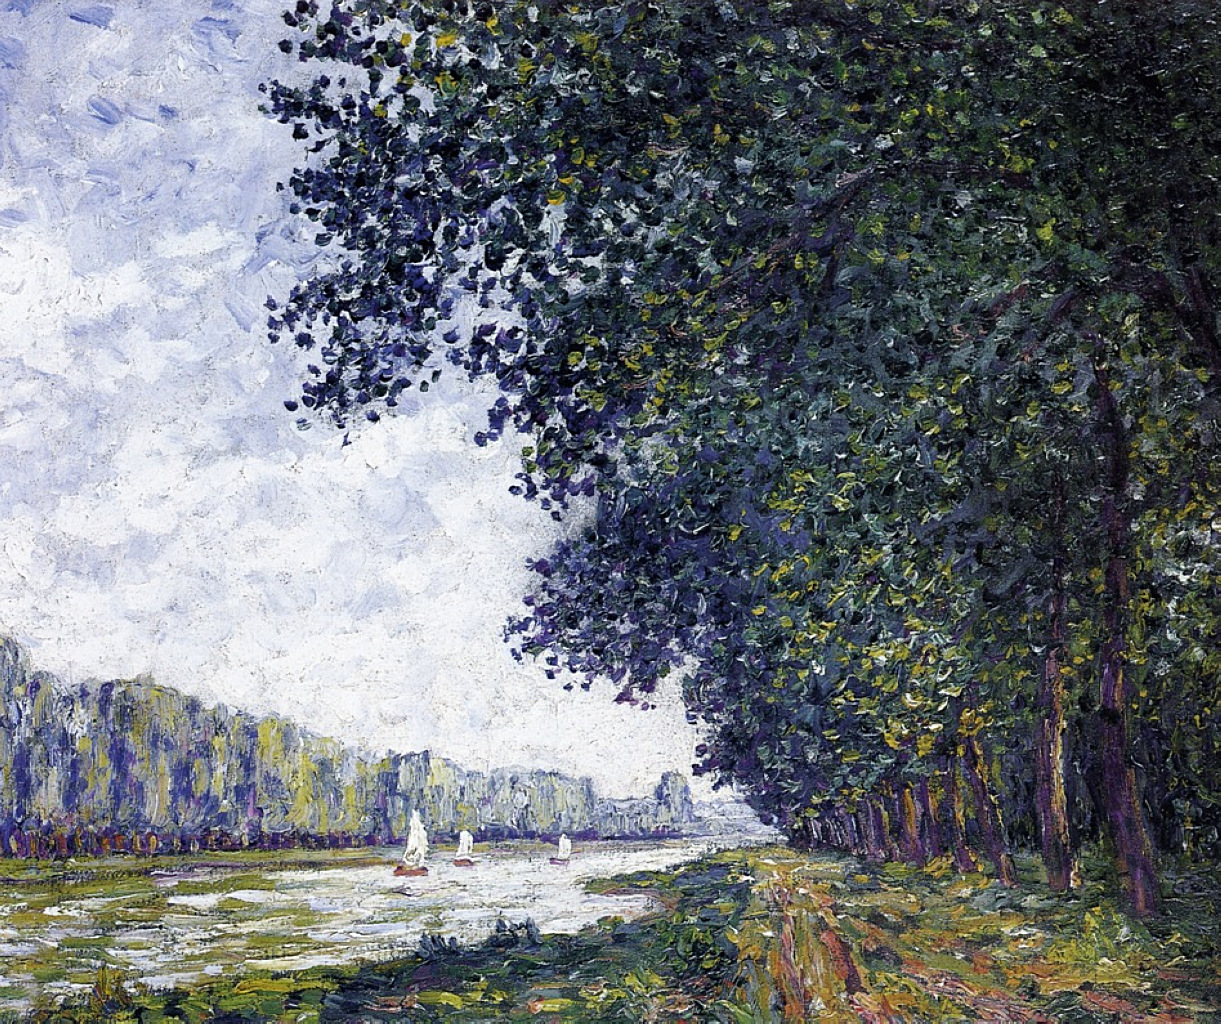Can you describe how the light is used throughout the painting? In the painting, light is masterfully used to evoke a sense of time and mood. The soft, diffused light suggests a calm, serene day with perhaps a few clouds filtering the sunlight. Light reflections on the water create a shimmering effect, enhancing the tranquility of the scene. The sunlight gently illuminates the leaves of the trees and casts subtle shadows, adding depth and dimension to the landscape. The use of light not only accentuates the natural beauty of the scene but also reinforces the peaceful ambiance that permeates the painting. What might the artist have felt or intended to convey with this painting? The artist likely intended to convey a sense of peace, serenity, and the ephemeral beauty of nature. By capturing a calm, idyllic scene with gentle sailboats and lush greenery, the artist might have sought to invite viewers into a moment of contemplation and relaxation. The painter's choice of a soothing color palette and the visible brushstrokes creating a sense of movement could reflect an admiration for the natural world and a desire to preserve the fleeting moments of tranquility it offers. If the trees could speak, what stories might they tell? If the trees could speak, they might recount tales of countless seasons passing, of summers where families picnicked beneath their shade, and of autumns where leaves turned golden and fell softly to the ground. They would share stories of lovers carving initials into their bark, sailors navigating the river, and children playing hide-and-seek among their trunks. Each tree would have its own unique history, filled with moments of joy, change, and quiet strength, creating a rich tapestry of the lives that intersected with theirs over the years. 